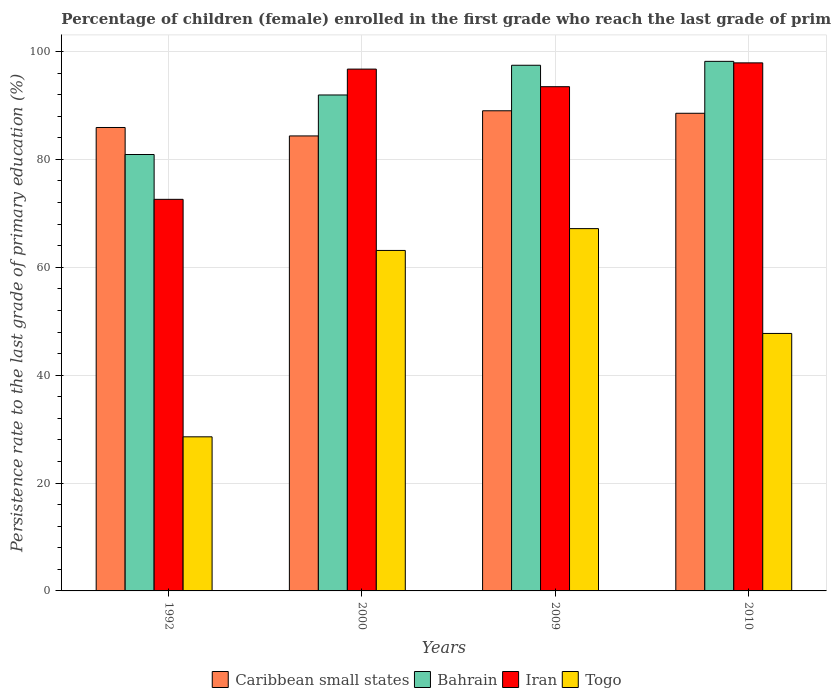Are the number of bars on each tick of the X-axis equal?
Make the answer very short. Yes. How many bars are there on the 2nd tick from the right?
Keep it short and to the point. 4. What is the label of the 4th group of bars from the left?
Keep it short and to the point. 2010. What is the persistence rate of children in Togo in 2010?
Provide a succinct answer. 47.74. Across all years, what is the maximum persistence rate of children in Iran?
Keep it short and to the point. 97.9. Across all years, what is the minimum persistence rate of children in Iran?
Provide a short and direct response. 72.6. In which year was the persistence rate of children in Togo maximum?
Your response must be concise. 2009. In which year was the persistence rate of children in Caribbean small states minimum?
Give a very brief answer. 2000. What is the total persistence rate of children in Togo in the graph?
Offer a very short reply. 206.6. What is the difference between the persistence rate of children in Bahrain in 1992 and that in 2009?
Provide a short and direct response. -16.55. What is the difference between the persistence rate of children in Bahrain in 2010 and the persistence rate of children in Togo in 2009?
Make the answer very short. 31.01. What is the average persistence rate of children in Togo per year?
Your answer should be compact. 51.65. In the year 2010, what is the difference between the persistence rate of children in Bahrain and persistence rate of children in Caribbean small states?
Your answer should be very brief. 9.63. What is the ratio of the persistence rate of children in Iran in 1992 to that in 2010?
Offer a very short reply. 0.74. What is the difference between the highest and the second highest persistence rate of children in Togo?
Your response must be concise. 4.05. What is the difference between the highest and the lowest persistence rate of children in Bahrain?
Give a very brief answer. 17.27. What does the 4th bar from the left in 2000 represents?
Your response must be concise. Togo. What does the 4th bar from the right in 2009 represents?
Make the answer very short. Caribbean small states. Is it the case that in every year, the sum of the persistence rate of children in Bahrain and persistence rate of children in Iran is greater than the persistence rate of children in Caribbean small states?
Provide a succinct answer. Yes. How many bars are there?
Keep it short and to the point. 16. How many years are there in the graph?
Your answer should be compact. 4. What is the difference between two consecutive major ticks on the Y-axis?
Ensure brevity in your answer.  20. Are the values on the major ticks of Y-axis written in scientific E-notation?
Give a very brief answer. No. What is the title of the graph?
Offer a terse response. Percentage of children (female) enrolled in the first grade who reach the last grade of primary education. What is the label or title of the X-axis?
Your answer should be very brief. Years. What is the label or title of the Y-axis?
Offer a terse response. Persistence rate to the last grade of primary education (%). What is the Persistence rate to the last grade of primary education (%) of Caribbean small states in 1992?
Provide a short and direct response. 85.92. What is the Persistence rate to the last grade of primary education (%) of Bahrain in 1992?
Ensure brevity in your answer.  80.91. What is the Persistence rate to the last grade of primary education (%) of Iran in 1992?
Your answer should be very brief. 72.6. What is the Persistence rate to the last grade of primary education (%) in Togo in 1992?
Make the answer very short. 28.57. What is the Persistence rate to the last grade of primary education (%) in Caribbean small states in 2000?
Your answer should be very brief. 84.36. What is the Persistence rate to the last grade of primary education (%) in Bahrain in 2000?
Your response must be concise. 91.95. What is the Persistence rate to the last grade of primary education (%) in Iran in 2000?
Keep it short and to the point. 96.74. What is the Persistence rate to the last grade of primary education (%) of Togo in 2000?
Make the answer very short. 63.13. What is the Persistence rate to the last grade of primary education (%) of Caribbean small states in 2009?
Offer a terse response. 89.02. What is the Persistence rate to the last grade of primary education (%) of Bahrain in 2009?
Your answer should be very brief. 97.46. What is the Persistence rate to the last grade of primary education (%) in Iran in 2009?
Keep it short and to the point. 93.49. What is the Persistence rate to the last grade of primary education (%) of Togo in 2009?
Offer a very short reply. 67.17. What is the Persistence rate to the last grade of primary education (%) in Caribbean small states in 2010?
Give a very brief answer. 88.56. What is the Persistence rate to the last grade of primary education (%) in Bahrain in 2010?
Provide a succinct answer. 98.18. What is the Persistence rate to the last grade of primary education (%) of Iran in 2010?
Your answer should be compact. 97.9. What is the Persistence rate to the last grade of primary education (%) of Togo in 2010?
Offer a terse response. 47.74. Across all years, what is the maximum Persistence rate to the last grade of primary education (%) in Caribbean small states?
Ensure brevity in your answer.  89.02. Across all years, what is the maximum Persistence rate to the last grade of primary education (%) in Bahrain?
Keep it short and to the point. 98.18. Across all years, what is the maximum Persistence rate to the last grade of primary education (%) of Iran?
Make the answer very short. 97.9. Across all years, what is the maximum Persistence rate to the last grade of primary education (%) of Togo?
Your answer should be compact. 67.17. Across all years, what is the minimum Persistence rate to the last grade of primary education (%) in Caribbean small states?
Offer a very short reply. 84.36. Across all years, what is the minimum Persistence rate to the last grade of primary education (%) of Bahrain?
Ensure brevity in your answer.  80.91. Across all years, what is the minimum Persistence rate to the last grade of primary education (%) of Iran?
Keep it short and to the point. 72.6. Across all years, what is the minimum Persistence rate to the last grade of primary education (%) in Togo?
Your answer should be very brief. 28.57. What is the total Persistence rate to the last grade of primary education (%) of Caribbean small states in the graph?
Ensure brevity in your answer.  347.85. What is the total Persistence rate to the last grade of primary education (%) in Bahrain in the graph?
Your answer should be compact. 368.5. What is the total Persistence rate to the last grade of primary education (%) in Iran in the graph?
Offer a very short reply. 360.73. What is the total Persistence rate to the last grade of primary education (%) in Togo in the graph?
Ensure brevity in your answer.  206.6. What is the difference between the Persistence rate to the last grade of primary education (%) of Caribbean small states in 1992 and that in 2000?
Keep it short and to the point. 1.56. What is the difference between the Persistence rate to the last grade of primary education (%) in Bahrain in 1992 and that in 2000?
Give a very brief answer. -11.04. What is the difference between the Persistence rate to the last grade of primary education (%) of Iran in 1992 and that in 2000?
Ensure brevity in your answer.  -24.14. What is the difference between the Persistence rate to the last grade of primary education (%) in Togo in 1992 and that in 2000?
Provide a short and direct response. -34.56. What is the difference between the Persistence rate to the last grade of primary education (%) in Caribbean small states in 1992 and that in 2009?
Provide a succinct answer. -3.1. What is the difference between the Persistence rate to the last grade of primary education (%) in Bahrain in 1992 and that in 2009?
Your answer should be very brief. -16.55. What is the difference between the Persistence rate to the last grade of primary education (%) of Iran in 1992 and that in 2009?
Give a very brief answer. -20.88. What is the difference between the Persistence rate to the last grade of primary education (%) of Togo in 1992 and that in 2009?
Offer a terse response. -38.6. What is the difference between the Persistence rate to the last grade of primary education (%) of Caribbean small states in 1992 and that in 2010?
Your answer should be very brief. -2.64. What is the difference between the Persistence rate to the last grade of primary education (%) of Bahrain in 1992 and that in 2010?
Keep it short and to the point. -17.27. What is the difference between the Persistence rate to the last grade of primary education (%) in Iran in 1992 and that in 2010?
Give a very brief answer. -25.3. What is the difference between the Persistence rate to the last grade of primary education (%) of Togo in 1992 and that in 2010?
Provide a succinct answer. -19.17. What is the difference between the Persistence rate to the last grade of primary education (%) in Caribbean small states in 2000 and that in 2009?
Give a very brief answer. -4.66. What is the difference between the Persistence rate to the last grade of primary education (%) of Bahrain in 2000 and that in 2009?
Give a very brief answer. -5.51. What is the difference between the Persistence rate to the last grade of primary education (%) in Iran in 2000 and that in 2009?
Make the answer very short. 3.26. What is the difference between the Persistence rate to the last grade of primary education (%) of Togo in 2000 and that in 2009?
Make the answer very short. -4.05. What is the difference between the Persistence rate to the last grade of primary education (%) in Caribbean small states in 2000 and that in 2010?
Give a very brief answer. -4.2. What is the difference between the Persistence rate to the last grade of primary education (%) in Bahrain in 2000 and that in 2010?
Keep it short and to the point. -6.23. What is the difference between the Persistence rate to the last grade of primary education (%) in Iran in 2000 and that in 2010?
Make the answer very short. -1.16. What is the difference between the Persistence rate to the last grade of primary education (%) of Togo in 2000 and that in 2010?
Your response must be concise. 15.39. What is the difference between the Persistence rate to the last grade of primary education (%) of Caribbean small states in 2009 and that in 2010?
Provide a short and direct response. 0.46. What is the difference between the Persistence rate to the last grade of primary education (%) in Bahrain in 2009 and that in 2010?
Offer a very short reply. -0.72. What is the difference between the Persistence rate to the last grade of primary education (%) of Iran in 2009 and that in 2010?
Make the answer very short. -4.42. What is the difference between the Persistence rate to the last grade of primary education (%) of Togo in 2009 and that in 2010?
Provide a succinct answer. 19.43. What is the difference between the Persistence rate to the last grade of primary education (%) in Caribbean small states in 1992 and the Persistence rate to the last grade of primary education (%) in Bahrain in 2000?
Provide a succinct answer. -6.03. What is the difference between the Persistence rate to the last grade of primary education (%) of Caribbean small states in 1992 and the Persistence rate to the last grade of primary education (%) of Iran in 2000?
Offer a very short reply. -10.82. What is the difference between the Persistence rate to the last grade of primary education (%) in Caribbean small states in 1992 and the Persistence rate to the last grade of primary education (%) in Togo in 2000?
Give a very brief answer. 22.79. What is the difference between the Persistence rate to the last grade of primary education (%) of Bahrain in 1992 and the Persistence rate to the last grade of primary education (%) of Iran in 2000?
Offer a very short reply. -15.83. What is the difference between the Persistence rate to the last grade of primary education (%) of Bahrain in 1992 and the Persistence rate to the last grade of primary education (%) of Togo in 2000?
Your response must be concise. 17.79. What is the difference between the Persistence rate to the last grade of primary education (%) of Iran in 1992 and the Persistence rate to the last grade of primary education (%) of Togo in 2000?
Keep it short and to the point. 9.47. What is the difference between the Persistence rate to the last grade of primary education (%) in Caribbean small states in 1992 and the Persistence rate to the last grade of primary education (%) in Bahrain in 2009?
Keep it short and to the point. -11.54. What is the difference between the Persistence rate to the last grade of primary education (%) in Caribbean small states in 1992 and the Persistence rate to the last grade of primary education (%) in Iran in 2009?
Keep it short and to the point. -7.56. What is the difference between the Persistence rate to the last grade of primary education (%) in Caribbean small states in 1992 and the Persistence rate to the last grade of primary education (%) in Togo in 2009?
Offer a terse response. 18.75. What is the difference between the Persistence rate to the last grade of primary education (%) in Bahrain in 1992 and the Persistence rate to the last grade of primary education (%) in Iran in 2009?
Make the answer very short. -12.57. What is the difference between the Persistence rate to the last grade of primary education (%) in Bahrain in 1992 and the Persistence rate to the last grade of primary education (%) in Togo in 2009?
Your response must be concise. 13.74. What is the difference between the Persistence rate to the last grade of primary education (%) of Iran in 1992 and the Persistence rate to the last grade of primary education (%) of Togo in 2009?
Provide a succinct answer. 5.43. What is the difference between the Persistence rate to the last grade of primary education (%) in Caribbean small states in 1992 and the Persistence rate to the last grade of primary education (%) in Bahrain in 2010?
Provide a short and direct response. -12.26. What is the difference between the Persistence rate to the last grade of primary education (%) in Caribbean small states in 1992 and the Persistence rate to the last grade of primary education (%) in Iran in 2010?
Your answer should be very brief. -11.98. What is the difference between the Persistence rate to the last grade of primary education (%) of Caribbean small states in 1992 and the Persistence rate to the last grade of primary education (%) of Togo in 2010?
Provide a succinct answer. 38.18. What is the difference between the Persistence rate to the last grade of primary education (%) of Bahrain in 1992 and the Persistence rate to the last grade of primary education (%) of Iran in 2010?
Ensure brevity in your answer.  -16.99. What is the difference between the Persistence rate to the last grade of primary education (%) of Bahrain in 1992 and the Persistence rate to the last grade of primary education (%) of Togo in 2010?
Offer a terse response. 33.17. What is the difference between the Persistence rate to the last grade of primary education (%) of Iran in 1992 and the Persistence rate to the last grade of primary education (%) of Togo in 2010?
Ensure brevity in your answer.  24.86. What is the difference between the Persistence rate to the last grade of primary education (%) of Caribbean small states in 2000 and the Persistence rate to the last grade of primary education (%) of Bahrain in 2009?
Provide a succinct answer. -13.1. What is the difference between the Persistence rate to the last grade of primary education (%) of Caribbean small states in 2000 and the Persistence rate to the last grade of primary education (%) of Iran in 2009?
Your answer should be very brief. -9.13. What is the difference between the Persistence rate to the last grade of primary education (%) in Caribbean small states in 2000 and the Persistence rate to the last grade of primary education (%) in Togo in 2009?
Ensure brevity in your answer.  17.19. What is the difference between the Persistence rate to the last grade of primary education (%) in Bahrain in 2000 and the Persistence rate to the last grade of primary education (%) in Iran in 2009?
Make the answer very short. -1.54. What is the difference between the Persistence rate to the last grade of primary education (%) of Bahrain in 2000 and the Persistence rate to the last grade of primary education (%) of Togo in 2009?
Offer a terse response. 24.78. What is the difference between the Persistence rate to the last grade of primary education (%) of Iran in 2000 and the Persistence rate to the last grade of primary education (%) of Togo in 2009?
Provide a succinct answer. 29.57. What is the difference between the Persistence rate to the last grade of primary education (%) in Caribbean small states in 2000 and the Persistence rate to the last grade of primary education (%) in Bahrain in 2010?
Your answer should be very brief. -13.83. What is the difference between the Persistence rate to the last grade of primary education (%) of Caribbean small states in 2000 and the Persistence rate to the last grade of primary education (%) of Iran in 2010?
Offer a terse response. -13.55. What is the difference between the Persistence rate to the last grade of primary education (%) of Caribbean small states in 2000 and the Persistence rate to the last grade of primary education (%) of Togo in 2010?
Make the answer very short. 36.62. What is the difference between the Persistence rate to the last grade of primary education (%) in Bahrain in 2000 and the Persistence rate to the last grade of primary education (%) in Iran in 2010?
Provide a short and direct response. -5.95. What is the difference between the Persistence rate to the last grade of primary education (%) of Bahrain in 2000 and the Persistence rate to the last grade of primary education (%) of Togo in 2010?
Your answer should be compact. 44.21. What is the difference between the Persistence rate to the last grade of primary education (%) in Iran in 2000 and the Persistence rate to the last grade of primary education (%) in Togo in 2010?
Offer a terse response. 49.01. What is the difference between the Persistence rate to the last grade of primary education (%) in Caribbean small states in 2009 and the Persistence rate to the last grade of primary education (%) in Bahrain in 2010?
Provide a short and direct response. -9.16. What is the difference between the Persistence rate to the last grade of primary education (%) of Caribbean small states in 2009 and the Persistence rate to the last grade of primary education (%) of Iran in 2010?
Your answer should be very brief. -8.88. What is the difference between the Persistence rate to the last grade of primary education (%) in Caribbean small states in 2009 and the Persistence rate to the last grade of primary education (%) in Togo in 2010?
Provide a succinct answer. 41.28. What is the difference between the Persistence rate to the last grade of primary education (%) of Bahrain in 2009 and the Persistence rate to the last grade of primary education (%) of Iran in 2010?
Make the answer very short. -0.44. What is the difference between the Persistence rate to the last grade of primary education (%) in Bahrain in 2009 and the Persistence rate to the last grade of primary education (%) in Togo in 2010?
Ensure brevity in your answer.  49.72. What is the difference between the Persistence rate to the last grade of primary education (%) in Iran in 2009 and the Persistence rate to the last grade of primary education (%) in Togo in 2010?
Ensure brevity in your answer.  45.75. What is the average Persistence rate to the last grade of primary education (%) of Caribbean small states per year?
Keep it short and to the point. 86.96. What is the average Persistence rate to the last grade of primary education (%) of Bahrain per year?
Ensure brevity in your answer.  92.13. What is the average Persistence rate to the last grade of primary education (%) in Iran per year?
Keep it short and to the point. 90.18. What is the average Persistence rate to the last grade of primary education (%) in Togo per year?
Ensure brevity in your answer.  51.65. In the year 1992, what is the difference between the Persistence rate to the last grade of primary education (%) of Caribbean small states and Persistence rate to the last grade of primary education (%) of Bahrain?
Make the answer very short. 5.01. In the year 1992, what is the difference between the Persistence rate to the last grade of primary education (%) in Caribbean small states and Persistence rate to the last grade of primary education (%) in Iran?
Give a very brief answer. 13.32. In the year 1992, what is the difference between the Persistence rate to the last grade of primary education (%) of Caribbean small states and Persistence rate to the last grade of primary education (%) of Togo?
Make the answer very short. 57.35. In the year 1992, what is the difference between the Persistence rate to the last grade of primary education (%) in Bahrain and Persistence rate to the last grade of primary education (%) in Iran?
Your answer should be very brief. 8.31. In the year 1992, what is the difference between the Persistence rate to the last grade of primary education (%) in Bahrain and Persistence rate to the last grade of primary education (%) in Togo?
Make the answer very short. 52.34. In the year 1992, what is the difference between the Persistence rate to the last grade of primary education (%) in Iran and Persistence rate to the last grade of primary education (%) in Togo?
Offer a very short reply. 44.03. In the year 2000, what is the difference between the Persistence rate to the last grade of primary education (%) of Caribbean small states and Persistence rate to the last grade of primary education (%) of Bahrain?
Offer a terse response. -7.59. In the year 2000, what is the difference between the Persistence rate to the last grade of primary education (%) of Caribbean small states and Persistence rate to the last grade of primary education (%) of Iran?
Offer a very short reply. -12.39. In the year 2000, what is the difference between the Persistence rate to the last grade of primary education (%) of Caribbean small states and Persistence rate to the last grade of primary education (%) of Togo?
Your answer should be very brief. 21.23. In the year 2000, what is the difference between the Persistence rate to the last grade of primary education (%) of Bahrain and Persistence rate to the last grade of primary education (%) of Iran?
Your answer should be very brief. -4.8. In the year 2000, what is the difference between the Persistence rate to the last grade of primary education (%) in Bahrain and Persistence rate to the last grade of primary education (%) in Togo?
Your answer should be very brief. 28.82. In the year 2000, what is the difference between the Persistence rate to the last grade of primary education (%) of Iran and Persistence rate to the last grade of primary education (%) of Togo?
Offer a terse response. 33.62. In the year 2009, what is the difference between the Persistence rate to the last grade of primary education (%) in Caribbean small states and Persistence rate to the last grade of primary education (%) in Bahrain?
Provide a succinct answer. -8.44. In the year 2009, what is the difference between the Persistence rate to the last grade of primary education (%) in Caribbean small states and Persistence rate to the last grade of primary education (%) in Iran?
Your answer should be very brief. -4.47. In the year 2009, what is the difference between the Persistence rate to the last grade of primary education (%) in Caribbean small states and Persistence rate to the last grade of primary education (%) in Togo?
Provide a short and direct response. 21.85. In the year 2009, what is the difference between the Persistence rate to the last grade of primary education (%) in Bahrain and Persistence rate to the last grade of primary education (%) in Iran?
Keep it short and to the point. 3.97. In the year 2009, what is the difference between the Persistence rate to the last grade of primary education (%) in Bahrain and Persistence rate to the last grade of primary education (%) in Togo?
Make the answer very short. 30.29. In the year 2009, what is the difference between the Persistence rate to the last grade of primary education (%) in Iran and Persistence rate to the last grade of primary education (%) in Togo?
Your response must be concise. 26.31. In the year 2010, what is the difference between the Persistence rate to the last grade of primary education (%) in Caribbean small states and Persistence rate to the last grade of primary education (%) in Bahrain?
Make the answer very short. -9.63. In the year 2010, what is the difference between the Persistence rate to the last grade of primary education (%) of Caribbean small states and Persistence rate to the last grade of primary education (%) of Iran?
Give a very brief answer. -9.35. In the year 2010, what is the difference between the Persistence rate to the last grade of primary education (%) in Caribbean small states and Persistence rate to the last grade of primary education (%) in Togo?
Offer a terse response. 40.82. In the year 2010, what is the difference between the Persistence rate to the last grade of primary education (%) in Bahrain and Persistence rate to the last grade of primary education (%) in Iran?
Give a very brief answer. 0.28. In the year 2010, what is the difference between the Persistence rate to the last grade of primary education (%) in Bahrain and Persistence rate to the last grade of primary education (%) in Togo?
Your answer should be very brief. 50.45. In the year 2010, what is the difference between the Persistence rate to the last grade of primary education (%) in Iran and Persistence rate to the last grade of primary education (%) in Togo?
Your answer should be very brief. 50.16. What is the ratio of the Persistence rate to the last grade of primary education (%) of Caribbean small states in 1992 to that in 2000?
Keep it short and to the point. 1.02. What is the ratio of the Persistence rate to the last grade of primary education (%) of Iran in 1992 to that in 2000?
Your answer should be very brief. 0.75. What is the ratio of the Persistence rate to the last grade of primary education (%) of Togo in 1992 to that in 2000?
Your response must be concise. 0.45. What is the ratio of the Persistence rate to the last grade of primary education (%) in Caribbean small states in 1992 to that in 2009?
Keep it short and to the point. 0.97. What is the ratio of the Persistence rate to the last grade of primary education (%) of Bahrain in 1992 to that in 2009?
Offer a terse response. 0.83. What is the ratio of the Persistence rate to the last grade of primary education (%) of Iran in 1992 to that in 2009?
Provide a short and direct response. 0.78. What is the ratio of the Persistence rate to the last grade of primary education (%) in Togo in 1992 to that in 2009?
Give a very brief answer. 0.43. What is the ratio of the Persistence rate to the last grade of primary education (%) in Caribbean small states in 1992 to that in 2010?
Your answer should be very brief. 0.97. What is the ratio of the Persistence rate to the last grade of primary education (%) of Bahrain in 1992 to that in 2010?
Offer a very short reply. 0.82. What is the ratio of the Persistence rate to the last grade of primary education (%) in Iran in 1992 to that in 2010?
Provide a succinct answer. 0.74. What is the ratio of the Persistence rate to the last grade of primary education (%) in Togo in 1992 to that in 2010?
Your answer should be compact. 0.6. What is the ratio of the Persistence rate to the last grade of primary education (%) in Caribbean small states in 2000 to that in 2009?
Provide a succinct answer. 0.95. What is the ratio of the Persistence rate to the last grade of primary education (%) in Bahrain in 2000 to that in 2009?
Provide a succinct answer. 0.94. What is the ratio of the Persistence rate to the last grade of primary education (%) of Iran in 2000 to that in 2009?
Provide a succinct answer. 1.03. What is the ratio of the Persistence rate to the last grade of primary education (%) of Togo in 2000 to that in 2009?
Provide a short and direct response. 0.94. What is the ratio of the Persistence rate to the last grade of primary education (%) in Caribbean small states in 2000 to that in 2010?
Ensure brevity in your answer.  0.95. What is the ratio of the Persistence rate to the last grade of primary education (%) in Bahrain in 2000 to that in 2010?
Offer a very short reply. 0.94. What is the ratio of the Persistence rate to the last grade of primary education (%) in Togo in 2000 to that in 2010?
Ensure brevity in your answer.  1.32. What is the ratio of the Persistence rate to the last grade of primary education (%) in Caribbean small states in 2009 to that in 2010?
Your answer should be compact. 1.01. What is the ratio of the Persistence rate to the last grade of primary education (%) in Iran in 2009 to that in 2010?
Give a very brief answer. 0.95. What is the ratio of the Persistence rate to the last grade of primary education (%) in Togo in 2009 to that in 2010?
Provide a succinct answer. 1.41. What is the difference between the highest and the second highest Persistence rate to the last grade of primary education (%) in Caribbean small states?
Your answer should be compact. 0.46. What is the difference between the highest and the second highest Persistence rate to the last grade of primary education (%) of Bahrain?
Your answer should be compact. 0.72. What is the difference between the highest and the second highest Persistence rate to the last grade of primary education (%) of Iran?
Offer a terse response. 1.16. What is the difference between the highest and the second highest Persistence rate to the last grade of primary education (%) of Togo?
Your answer should be very brief. 4.05. What is the difference between the highest and the lowest Persistence rate to the last grade of primary education (%) in Caribbean small states?
Offer a very short reply. 4.66. What is the difference between the highest and the lowest Persistence rate to the last grade of primary education (%) in Bahrain?
Your answer should be very brief. 17.27. What is the difference between the highest and the lowest Persistence rate to the last grade of primary education (%) in Iran?
Make the answer very short. 25.3. What is the difference between the highest and the lowest Persistence rate to the last grade of primary education (%) of Togo?
Give a very brief answer. 38.6. 